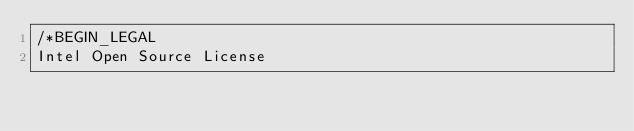Convert code to text. <code><loc_0><loc_0><loc_500><loc_500><_C++_>/*BEGIN_LEGAL 
Intel Open Source License 
</code> 